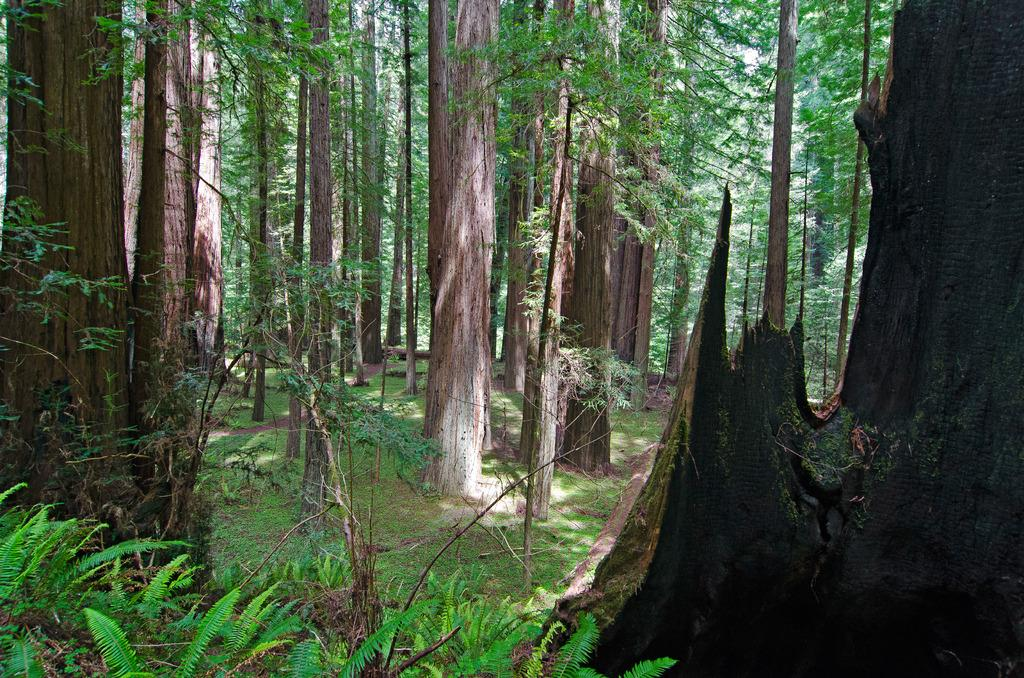What type of vegetation can be seen in the image? There are trees in the image. What is covering the ground in the image? There is grass on the ground in the image. How many girls are playing in the prison depicted in the image? There is no prison or girls present in the image; it features trees and grass. 